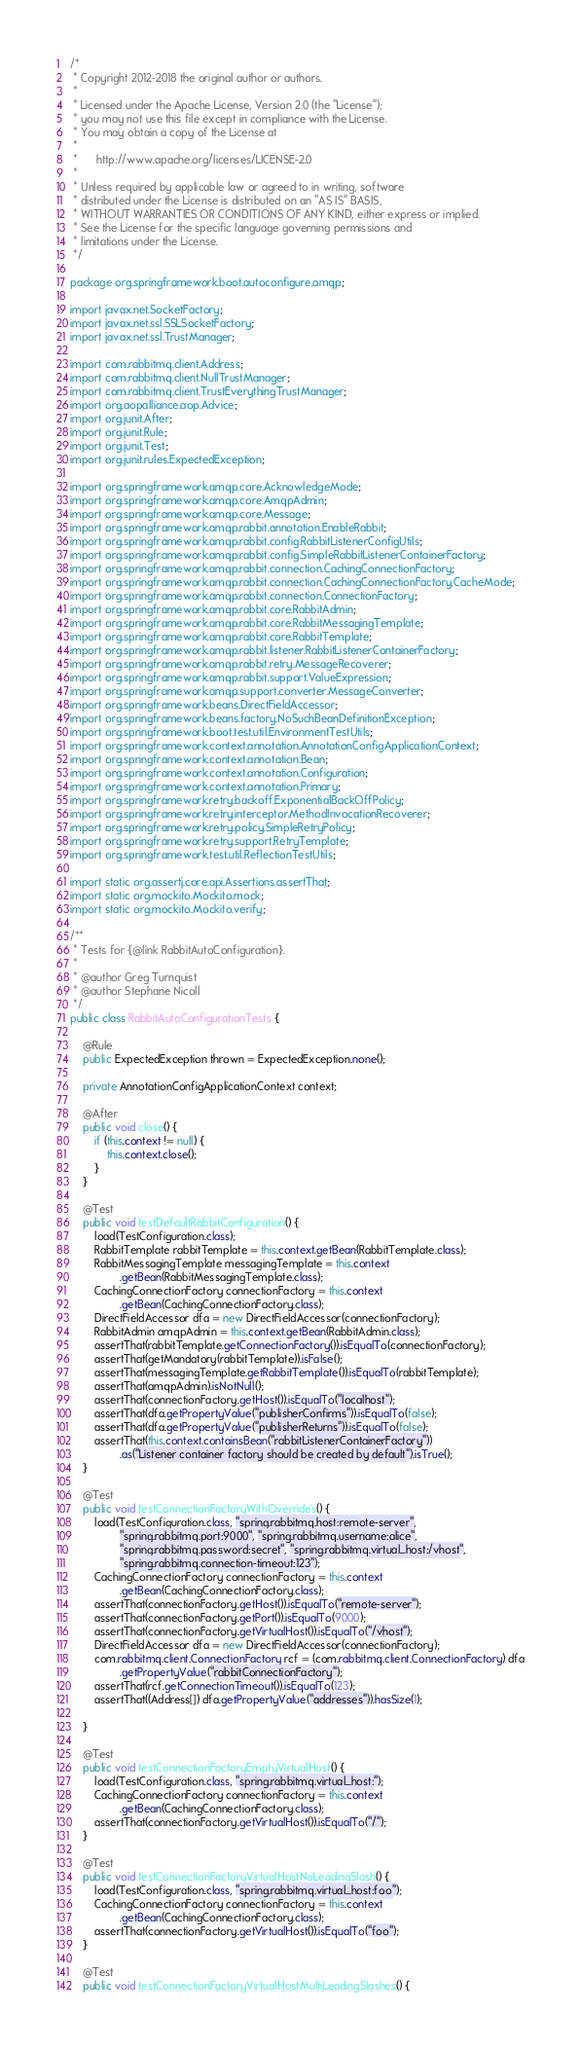<code> <loc_0><loc_0><loc_500><loc_500><_Java_>/*
 * Copyright 2012-2018 the original author or authors.
 *
 * Licensed under the Apache License, Version 2.0 (the "License");
 * you may not use this file except in compliance with the License.
 * You may obtain a copy of the License at
 *
 *      http://www.apache.org/licenses/LICENSE-2.0
 *
 * Unless required by applicable law or agreed to in writing, software
 * distributed under the License is distributed on an "AS IS" BASIS,
 * WITHOUT WARRANTIES OR CONDITIONS OF ANY KIND, either express or implied.
 * See the License for the specific language governing permissions and
 * limitations under the License.
 */

package org.springframework.boot.autoconfigure.amqp;

import javax.net.SocketFactory;
import javax.net.ssl.SSLSocketFactory;
import javax.net.ssl.TrustManager;

import com.rabbitmq.client.Address;
import com.rabbitmq.client.NullTrustManager;
import com.rabbitmq.client.TrustEverythingTrustManager;
import org.aopalliance.aop.Advice;
import org.junit.After;
import org.junit.Rule;
import org.junit.Test;
import org.junit.rules.ExpectedException;

import org.springframework.amqp.core.AcknowledgeMode;
import org.springframework.amqp.core.AmqpAdmin;
import org.springframework.amqp.core.Message;
import org.springframework.amqp.rabbit.annotation.EnableRabbit;
import org.springframework.amqp.rabbit.config.RabbitListenerConfigUtils;
import org.springframework.amqp.rabbit.config.SimpleRabbitListenerContainerFactory;
import org.springframework.amqp.rabbit.connection.CachingConnectionFactory;
import org.springframework.amqp.rabbit.connection.CachingConnectionFactory.CacheMode;
import org.springframework.amqp.rabbit.connection.ConnectionFactory;
import org.springframework.amqp.rabbit.core.RabbitAdmin;
import org.springframework.amqp.rabbit.core.RabbitMessagingTemplate;
import org.springframework.amqp.rabbit.core.RabbitTemplate;
import org.springframework.amqp.rabbit.listener.RabbitListenerContainerFactory;
import org.springframework.amqp.rabbit.retry.MessageRecoverer;
import org.springframework.amqp.rabbit.support.ValueExpression;
import org.springframework.amqp.support.converter.MessageConverter;
import org.springframework.beans.DirectFieldAccessor;
import org.springframework.beans.factory.NoSuchBeanDefinitionException;
import org.springframework.boot.test.util.EnvironmentTestUtils;
import org.springframework.context.annotation.AnnotationConfigApplicationContext;
import org.springframework.context.annotation.Bean;
import org.springframework.context.annotation.Configuration;
import org.springframework.context.annotation.Primary;
import org.springframework.retry.backoff.ExponentialBackOffPolicy;
import org.springframework.retry.interceptor.MethodInvocationRecoverer;
import org.springframework.retry.policy.SimpleRetryPolicy;
import org.springframework.retry.support.RetryTemplate;
import org.springframework.test.util.ReflectionTestUtils;

import static org.assertj.core.api.Assertions.assertThat;
import static org.mockito.Mockito.mock;
import static org.mockito.Mockito.verify;

/**
 * Tests for {@link RabbitAutoConfiguration}.
 *
 * @author Greg Turnquist
 * @author Stephane Nicoll
 */
public class RabbitAutoConfigurationTests {

	@Rule
	public ExpectedException thrown = ExpectedException.none();

	private AnnotationConfigApplicationContext context;

	@After
	public void close() {
		if (this.context != null) {
			this.context.close();
		}
	}

	@Test
	public void testDefaultRabbitConfiguration() {
		load(TestConfiguration.class);
		RabbitTemplate rabbitTemplate = this.context.getBean(RabbitTemplate.class);
		RabbitMessagingTemplate messagingTemplate = this.context
				.getBean(RabbitMessagingTemplate.class);
		CachingConnectionFactory connectionFactory = this.context
				.getBean(CachingConnectionFactory.class);
		DirectFieldAccessor dfa = new DirectFieldAccessor(connectionFactory);
		RabbitAdmin amqpAdmin = this.context.getBean(RabbitAdmin.class);
		assertThat(rabbitTemplate.getConnectionFactory()).isEqualTo(connectionFactory);
		assertThat(getMandatory(rabbitTemplate)).isFalse();
		assertThat(messagingTemplate.getRabbitTemplate()).isEqualTo(rabbitTemplate);
		assertThat(amqpAdmin).isNotNull();
		assertThat(connectionFactory.getHost()).isEqualTo("localhost");
		assertThat(dfa.getPropertyValue("publisherConfirms")).isEqualTo(false);
		assertThat(dfa.getPropertyValue("publisherReturns")).isEqualTo(false);
		assertThat(this.context.containsBean("rabbitListenerContainerFactory"))
				.as("Listener container factory should be created by default").isTrue();
	}

	@Test
	public void testConnectionFactoryWithOverrides() {
		load(TestConfiguration.class, "spring.rabbitmq.host:remote-server",
				"spring.rabbitmq.port:9000", "spring.rabbitmq.username:alice",
				"spring.rabbitmq.password:secret", "spring.rabbitmq.virtual_host:/vhost",
				"spring.rabbitmq.connection-timeout:123");
		CachingConnectionFactory connectionFactory = this.context
				.getBean(CachingConnectionFactory.class);
		assertThat(connectionFactory.getHost()).isEqualTo("remote-server");
		assertThat(connectionFactory.getPort()).isEqualTo(9000);
		assertThat(connectionFactory.getVirtualHost()).isEqualTo("/vhost");
		DirectFieldAccessor dfa = new DirectFieldAccessor(connectionFactory);
		com.rabbitmq.client.ConnectionFactory rcf = (com.rabbitmq.client.ConnectionFactory) dfa
				.getPropertyValue("rabbitConnectionFactory");
		assertThat(rcf.getConnectionTimeout()).isEqualTo(123);
		assertThat((Address[]) dfa.getPropertyValue("addresses")).hasSize(1);

	}

	@Test
	public void testConnectionFactoryEmptyVirtualHost() {
		load(TestConfiguration.class, "spring.rabbitmq.virtual_host:");
		CachingConnectionFactory connectionFactory = this.context
				.getBean(CachingConnectionFactory.class);
		assertThat(connectionFactory.getVirtualHost()).isEqualTo("/");
	}

	@Test
	public void testConnectionFactoryVirtualHostNoLeadingSlash() {
		load(TestConfiguration.class, "spring.rabbitmq.virtual_host:foo");
		CachingConnectionFactory connectionFactory = this.context
				.getBean(CachingConnectionFactory.class);
		assertThat(connectionFactory.getVirtualHost()).isEqualTo("foo");
	}

	@Test
	public void testConnectionFactoryVirtualHostMultiLeadingSlashes() {</code> 